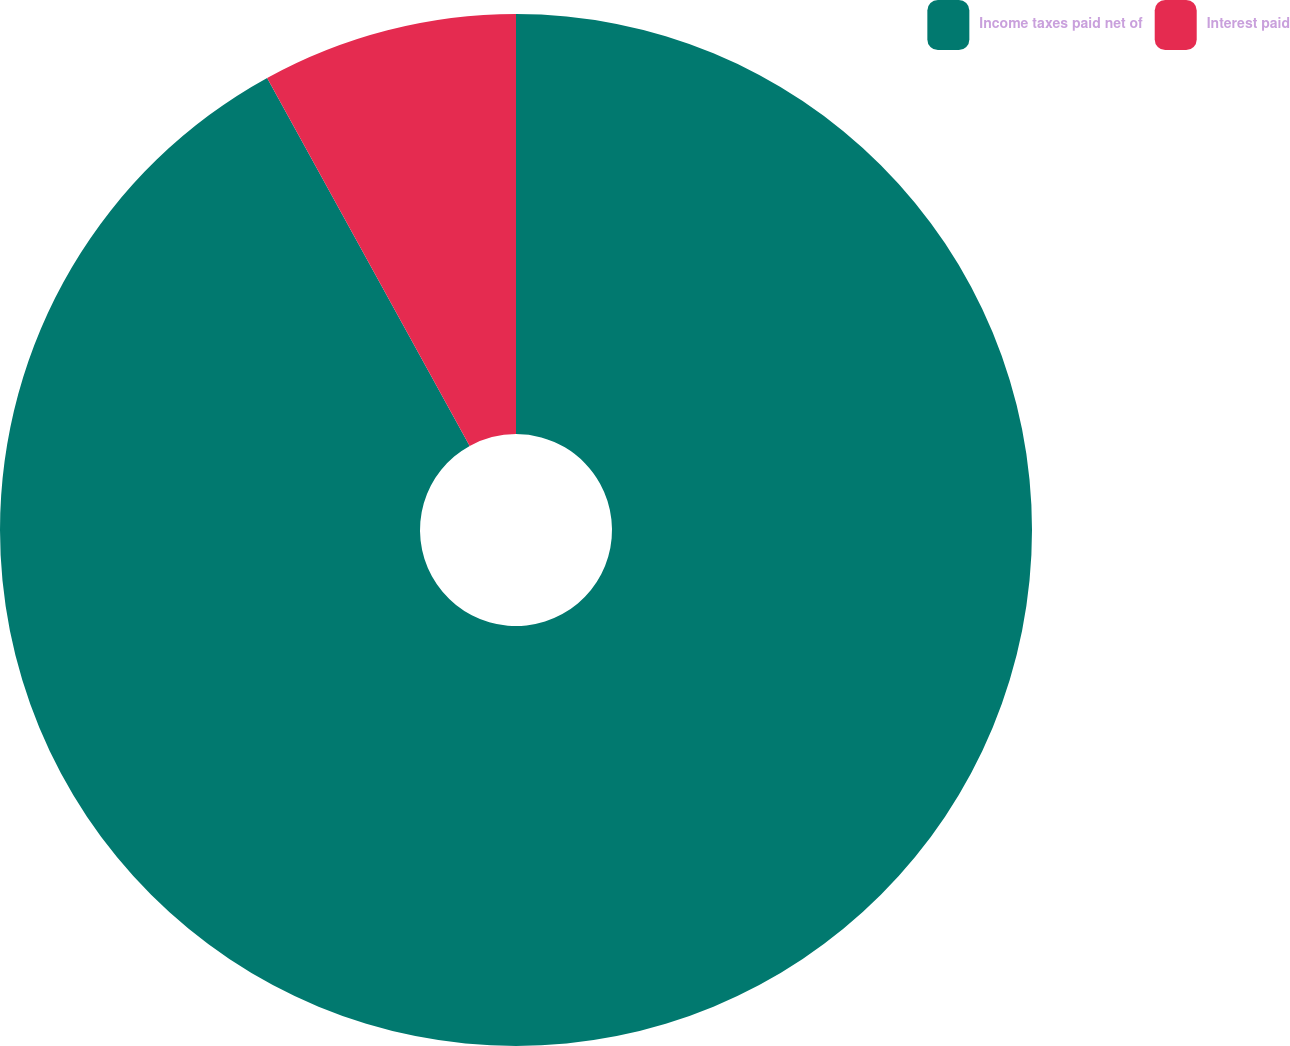<chart> <loc_0><loc_0><loc_500><loc_500><pie_chart><fcel>Income taxes paid net of<fcel>Interest paid<nl><fcel>91.99%<fcel>8.01%<nl></chart> 